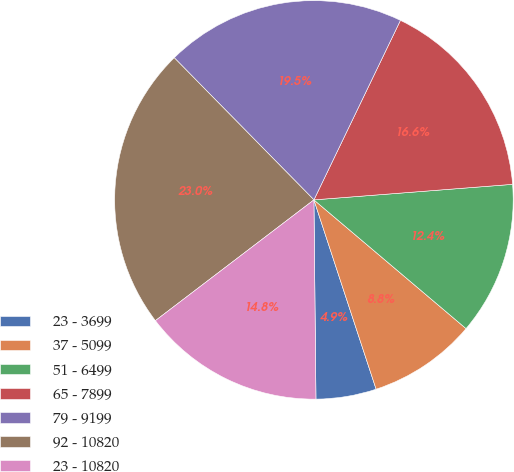Convert chart. <chart><loc_0><loc_0><loc_500><loc_500><pie_chart><fcel>23 - 3699<fcel>37 - 5099<fcel>51 - 6499<fcel>65 - 7899<fcel>79 - 9199<fcel>92 - 10820<fcel>23 - 10820<nl><fcel>4.89%<fcel>8.77%<fcel>12.42%<fcel>16.61%<fcel>19.51%<fcel>23.0%<fcel>14.8%<nl></chart> 